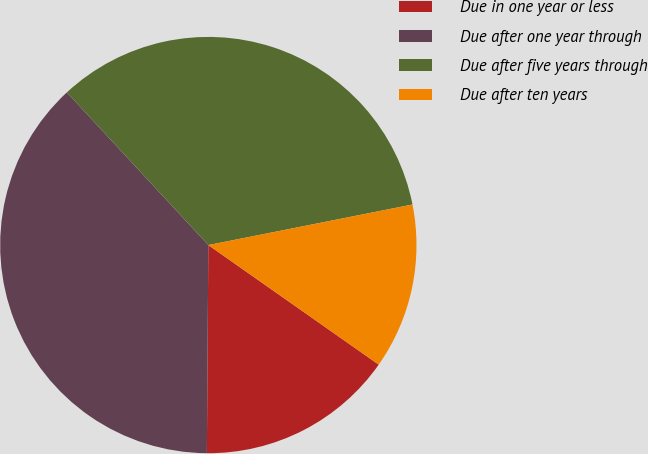<chart> <loc_0><loc_0><loc_500><loc_500><pie_chart><fcel>Due in one year or less<fcel>Due after one year through<fcel>Due after five years through<fcel>Due after ten years<nl><fcel>15.37%<fcel>37.99%<fcel>33.77%<fcel>12.86%<nl></chart> 